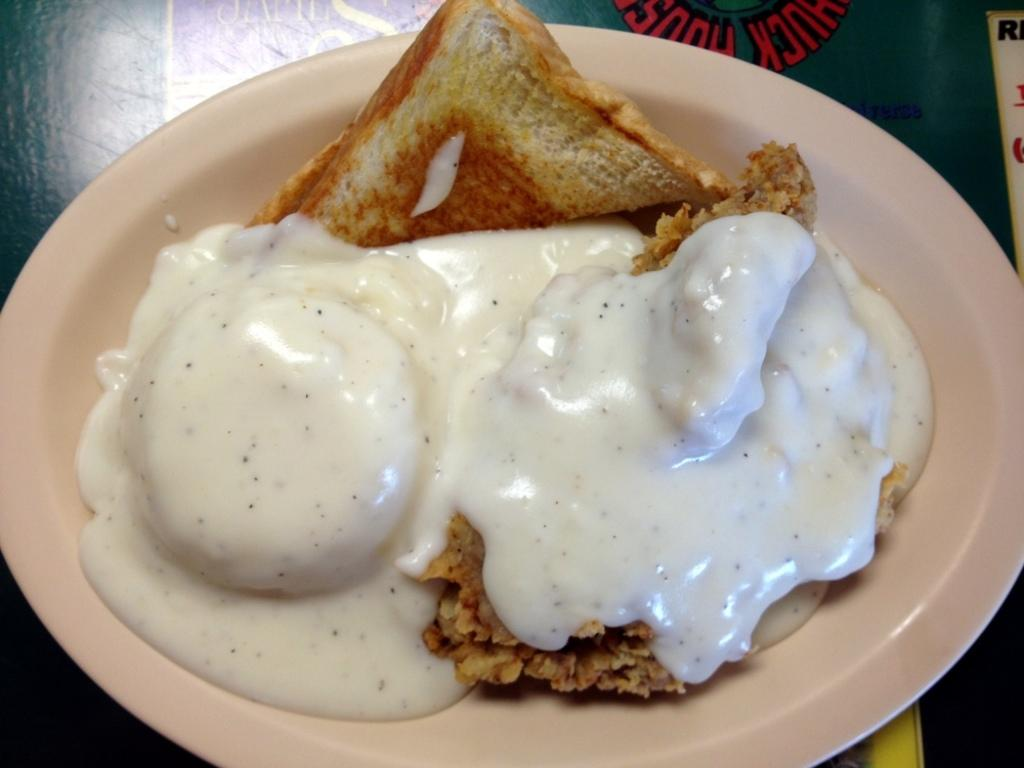What is the color of the surface in the image? The surface in the image is green. What can be found on the surface? There is a cream-colored plate on the surface. What is on the plate? There is a food item on the plate. Can you describe the appearance of the food item? The food item has brown, cream, and white colors. How many suits are visible in the image? There are no suits present in the image. Can you describe the way the horses are arranged in the image? There are no horses present in the image. 